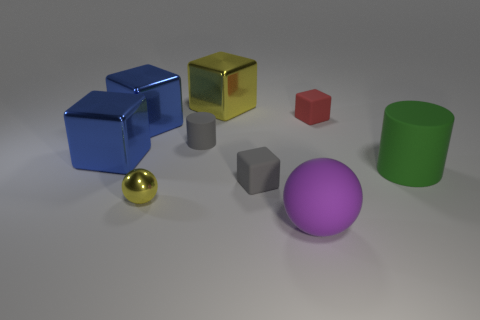What number of other things are the same material as the large purple thing?
Your answer should be compact. 4. Do the green rubber cylinder and the gray matte cube have the same size?
Ensure brevity in your answer.  No. How many balls are small red matte things or tiny metallic objects?
Your answer should be very brief. 1. What number of objects are both to the left of the purple sphere and in front of the small gray rubber cylinder?
Ensure brevity in your answer.  3. Is the size of the red thing the same as the rubber cylinder right of the purple ball?
Make the answer very short. No. There is a ball right of the tiny matte block on the left side of the small red object; are there any blocks that are left of it?
Your answer should be compact. Yes. What material is the cube that is behind the tiny object that is right of the rubber ball?
Provide a succinct answer. Metal. There is a object that is on the right side of the purple sphere and behind the big green rubber object; what material is it made of?
Give a very brief answer. Rubber. Is there a small gray rubber object that has the same shape as the green rubber object?
Your answer should be compact. Yes. Are there any matte objects that are in front of the small block right of the big purple sphere?
Keep it short and to the point. Yes. 